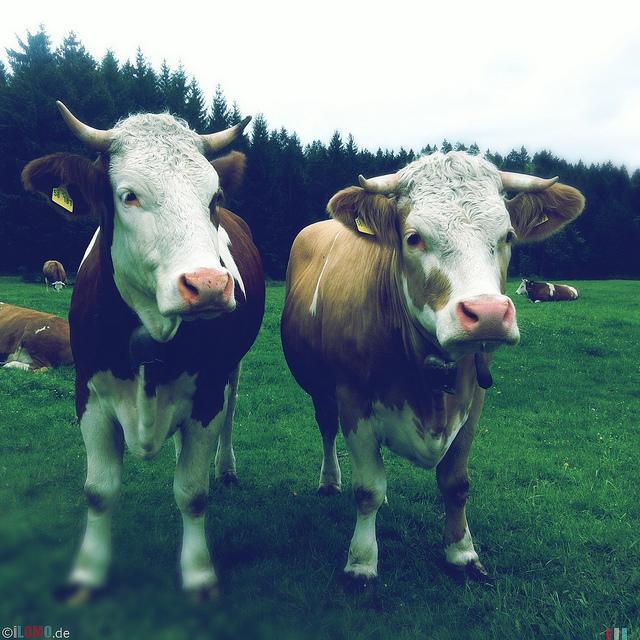How many cows are lying down in the background?
Give a very brief answer. 2. How many cows are there?
Give a very brief answer. 3. 